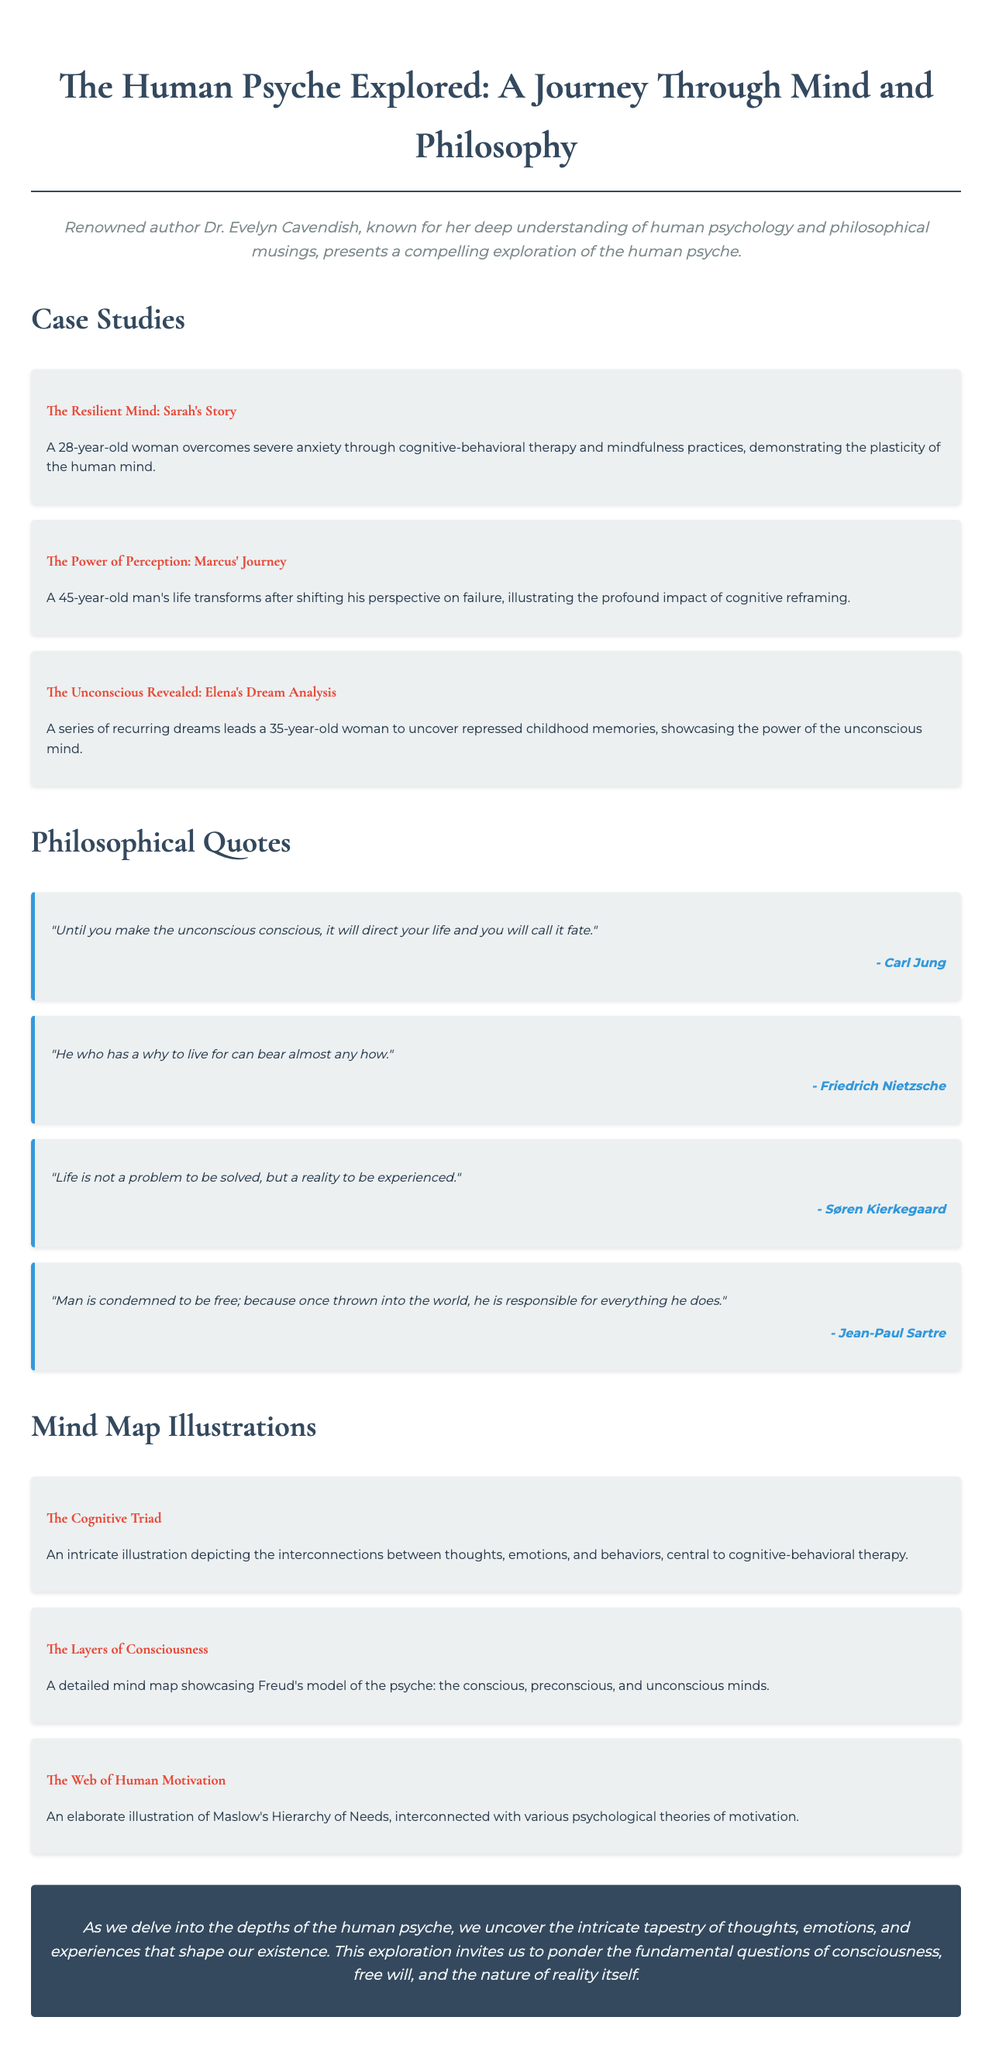What is the title of the brochure? The title of the brochure is presented at the top, summarizing the main theme.
Answer: The Human Psyche Explored: A Journey Through Mind and Philosophy Who is the author of the brochure? The brochure features an author bio indicating the creator of the content.
Answer: Dr. Evelyn Cavendish What age is Sarah, the subject of the first case study? The case study provides the age of Sarah, showcasing her journey of overcoming anxiety.
Answer: 28 What is the main theme of Marcus' journey? The description highlights the transformation in Marcus' life through a change in perspective.
Answer: Cognitive reframing Which psychological model is illustrated in "The Layers of Consciousness"? The brochure describes a detailed mind map related to a well-known psychological framework.
Answer: Freud's model of the psyche What quote is attributed to Carl Jung? The brochure includes various philosophical quotes, including one from Carl Jung.
Answer: Until you make the unconscious conscious, it will direct your life and you will call it fate How many case studies are featured in the brochure? By counting the individual case studies listed, we can determine the number discussed in the brochure.
Answer: Three What is the color theme of the brochure's background? The background color is mentioned in the document's styling information.
Answer: #f0ebe3 What conclusion does the brochure draw regarding the human psyche? The conclusion section summarizes the overarching insight offered by the brochure.
Answer: Intricate tapestry of thoughts, emotions, and experiences 